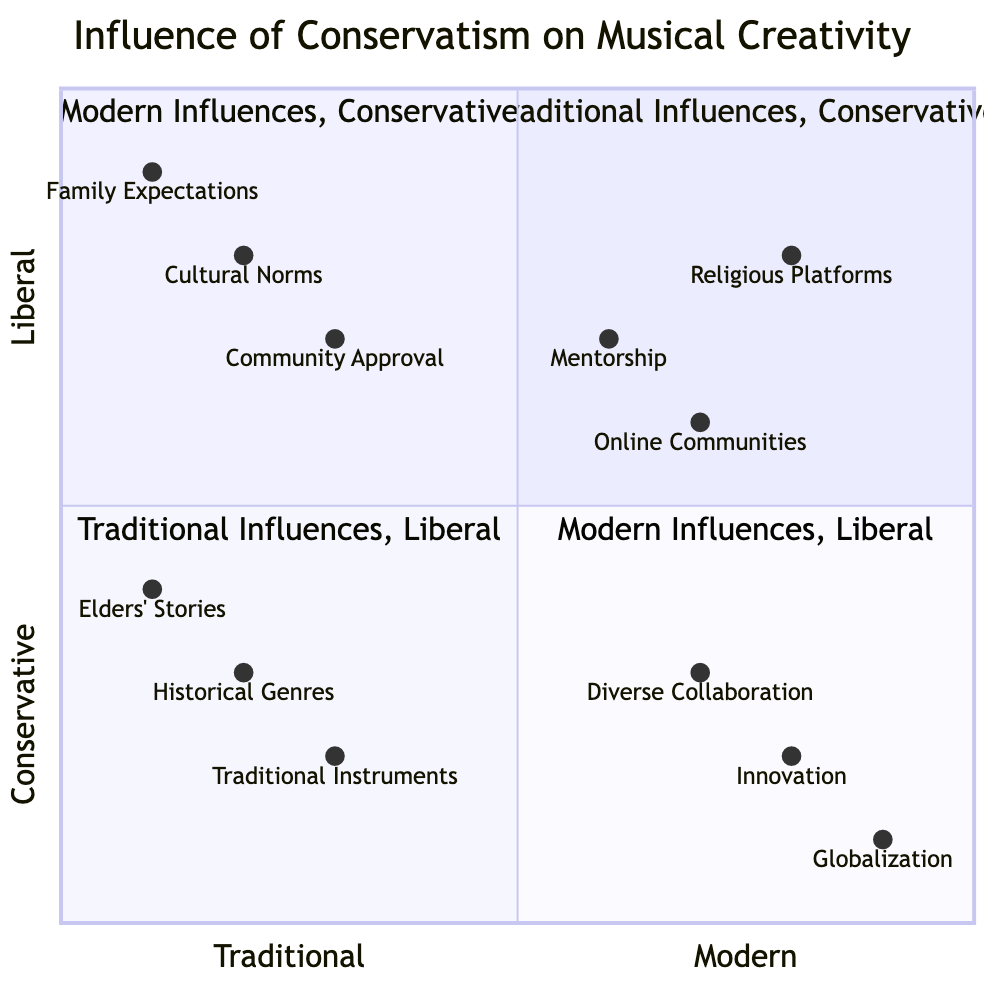What are the three entities in the Traditional Influences, Conservative quadrant? The question asks for specific entities located within that quadrant. By examining the diagram, I see that the three entities listed there are "Cultural Norms," "Family Expectations," and "Community Approval."
Answer: Cultural Norms, Family Expectations, Community Approval Which quadrant contains "Innovation"? "Innovation" is a specific entity within the diagram, and we can find it in the "Modern Influences, Liberal" quadrant. I confirm this by locating the entity within the chart.
Answer: Modern Influences, Liberal How many entities are present in the Modern Influences, Conservative quadrant? To answer this, I count the number of entities that fall into this specific quadrant. There are three entities listed: "Online Communities," "Mentorship," and "Religious Platforms."
Answer: 3 What is the description of "Elders' Stories"? This question requires locating the specific entity "Elders' Stories" and reading its corresponding description from the diagram. The description provided is "Learning about music through storytelling by older generations."
Answer: Learning about music through storytelling by older generations In which quadrant is "Globalization" located? The question involves identifying the quadrant position of the entity "Globalization." Checking the diagram, I find that it is in the "Modern Influences, Liberal" quadrant.
Answer: Modern Influences, Liberal What’s the relationship between Traditional Instruments and Historical Genres? This question seeks to understand the relationship in terms of their quadrants. Both "Traditional Instruments" and "Historical Genres" are located in the "Traditional Influences," but their characteristics vary: one is more cultural (instruments) while the other is historically focused (genres).
Answer: Both are in Traditional Influences How do the influences of "Online Communities" differ from "Cultural Norms"? Here, I will look at both entities' quadrants and descriptions. "Online Communities" represent a modern influence that connects people, while "Cultural Norms" reflect traditional values stating community adherence. The difference lies in modern connectivity versus traditional expectations.
Answer: Modern connectivity vs. traditional expectations Which entities are in the same quadrant as "Religious Platforms"? To answer this, I look for "Religious Platforms" and identify other entities within the same quadrant, which is the "Modern Influences, Conservative" quadrant. The other two entities are "Online Communities" and "Mentorship."
Answer: Online Communities, Mentorship What is the highest position entity in the diagram? The highest position refers to the upper section of the diagram (y-axis being liberal) and indicates the quadrant of higher liberal influences. That position contains "Globalization," which is the entity placed at the upper end of the y-axis.
Answer: Globalization 